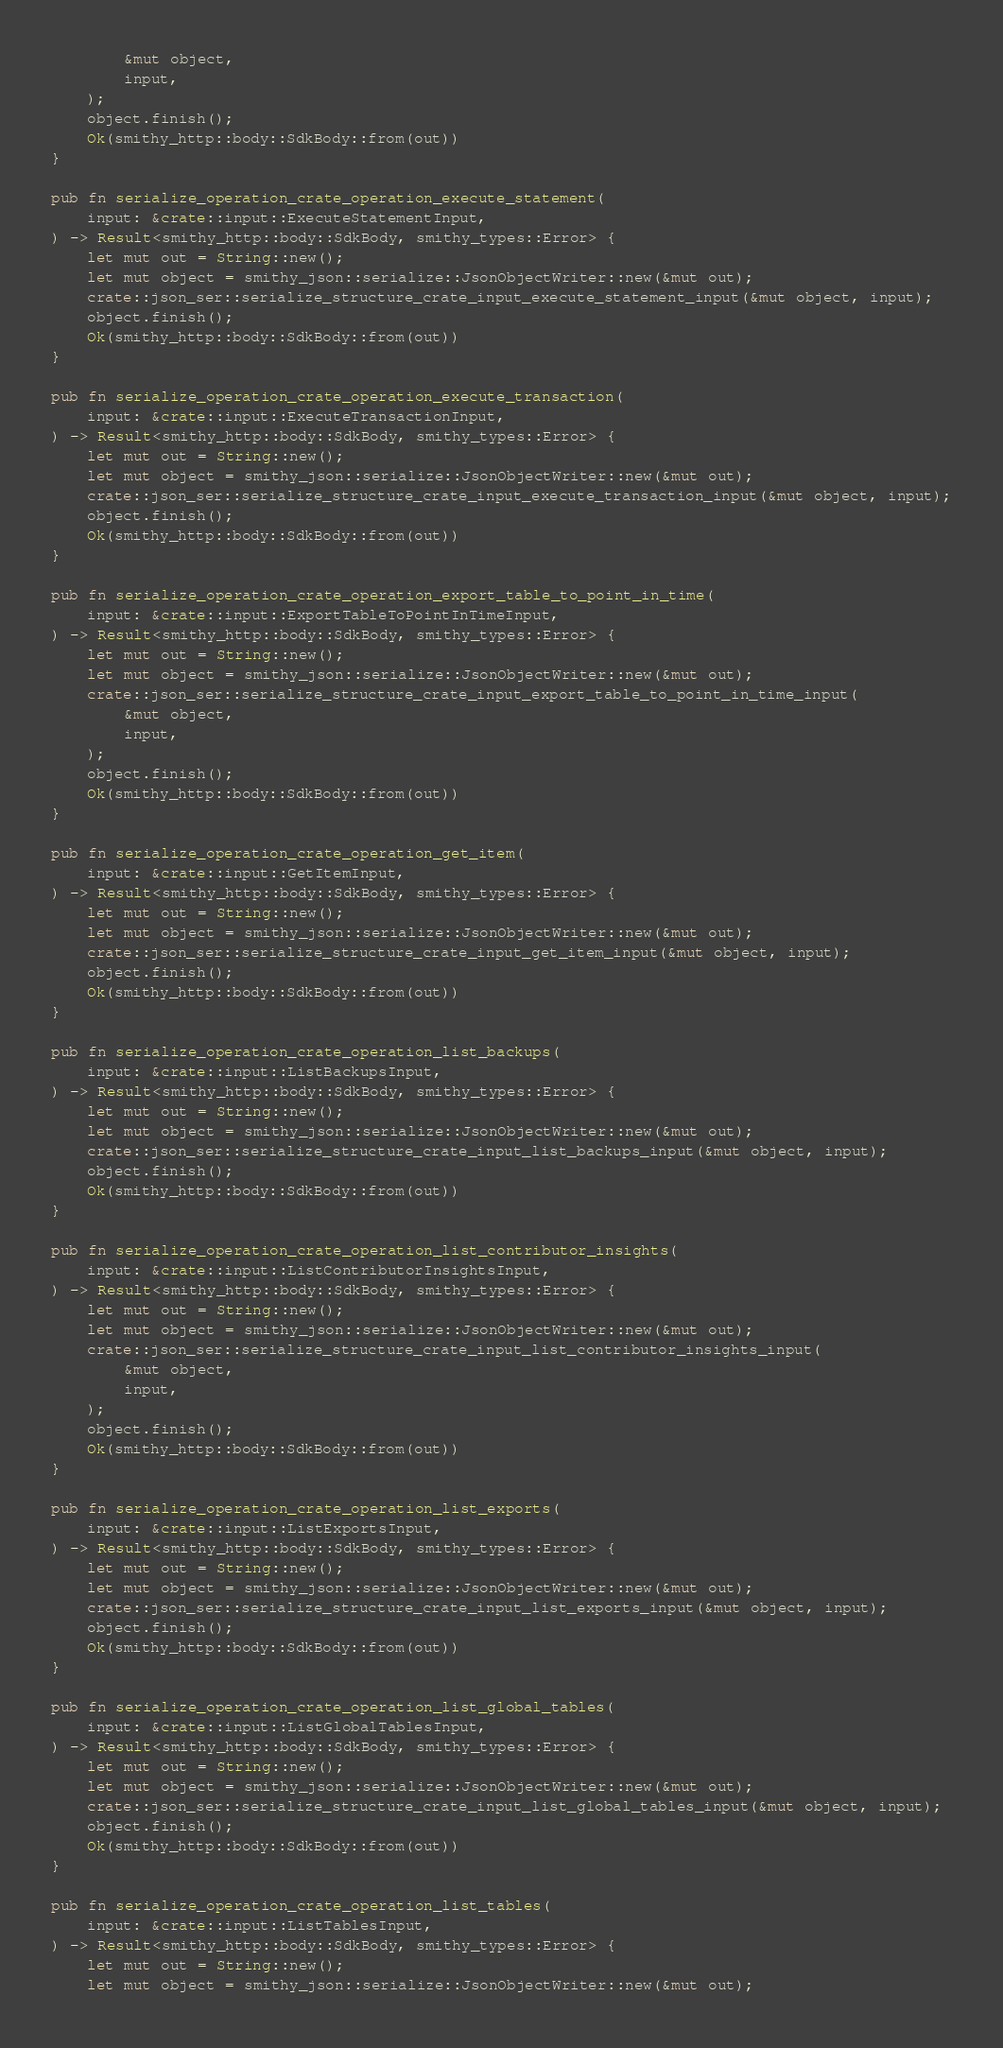<code> <loc_0><loc_0><loc_500><loc_500><_Rust_>        &mut object,
        input,
    );
    object.finish();
    Ok(smithy_http::body::SdkBody::from(out))
}

pub fn serialize_operation_crate_operation_execute_statement(
    input: &crate::input::ExecuteStatementInput,
) -> Result<smithy_http::body::SdkBody, smithy_types::Error> {
    let mut out = String::new();
    let mut object = smithy_json::serialize::JsonObjectWriter::new(&mut out);
    crate::json_ser::serialize_structure_crate_input_execute_statement_input(&mut object, input);
    object.finish();
    Ok(smithy_http::body::SdkBody::from(out))
}

pub fn serialize_operation_crate_operation_execute_transaction(
    input: &crate::input::ExecuteTransactionInput,
) -> Result<smithy_http::body::SdkBody, smithy_types::Error> {
    let mut out = String::new();
    let mut object = smithy_json::serialize::JsonObjectWriter::new(&mut out);
    crate::json_ser::serialize_structure_crate_input_execute_transaction_input(&mut object, input);
    object.finish();
    Ok(smithy_http::body::SdkBody::from(out))
}

pub fn serialize_operation_crate_operation_export_table_to_point_in_time(
    input: &crate::input::ExportTableToPointInTimeInput,
) -> Result<smithy_http::body::SdkBody, smithy_types::Error> {
    let mut out = String::new();
    let mut object = smithy_json::serialize::JsonObjectWriter::new(&mut out);
    crate::json_ser::serialize_structure_crate_input_export_table_to_point_in_time_input(
        &mut object,
        input,
    );
    object.finish();
    Ok(smithy_http::body::SdkBody::from(out))
}

pub fn serialize_operation_crate_operation_get_item(
    input: &crate::input::GetItemInput,
) -> Result<smithy_http::body::SdkBody, smithy_types::Error> {
    let mut out = String::new();
    let mut object = smithy_json::serialize::JsonObjectWriter::new(&mut out);
    crate::json_ser::serialize_structure_crate_input_get_item_input(&mut object, input);
    object.finish();
    Ok(smithy_http::body::SdkBody::from(out))
}

pub fn serialize_operation_crate_operation_list_backups(
    input: &crate::input::ListBackupsInput,
) -> Result<smithy_http::body::SdkBody, smithy_types::Error> {
    let mut out = String::new();
    let mut object = smithy_json::serialize::JsonObjectWriter::new(&mut out);
    crate::json_ser::serialize_structure_crate_input_list_backups_input(&mut object, input);
    object.finish();
    Ok(smithy_http::body::SdkBody::from(out))
}

pub fn serialize_operation_crate_operation_list_contributor_insights(
    input: &crate::input::ListContributorInsightsInput,
) -> Result<smithy_http::body::SdkBody, smithy_types::Error> {
    let mut out = String::new();
    let mut object = smithy_json::serialize::JsonObjectWriter::new(&mut out);
    crate::json_ser::serialize_structure_crate_input_list_contributor_insights_input(
        &mut object,
        input,
    );
    object.finish();
    Ok(smithy_http::body::SdkBody::from(out))
}

pub fn serialize_operation_crate_operation_list_exports(
    input: &crate::input::ListExportsInput,
) -> Result<smithy_http::body::SdkBody, smithy_types::Error> {
    let mut out = String::new();
    let mut object = smithy_json::serialize::JsonObjectWriter::new(&mut out);
    crate::json_ser::serialize_structure_crate_input_list_exports_input(&mut object, input);
    object.finish();
    Ok(smithy_http::body::SdkBody::from(out))
}

pub fn serialize_operation_crate_operation_list_global_tables(
    input: &crate::input::ListGlobalTablesInput,
) -> Result<smithy_http::body::SdkBody, smithy_types::Error> {
    let mut out = String::new();
    let mut object = smithy_json::serialize::JsonObjectWriter::new(&mut out);
    crate::json_ser::serialize_structure_crate_input_list_global_tables_input(&mut object, input);
    object.finish();
    Ok(smithy_http::body::SdkBody::from(out))
}

pub fn serialize_operation_crate_operation_list_tables(
    input: &crate::input::ListTablesInput,
) -> Result<smithy_http::body::SdkBody, smithy_types::Error> {
    let mut out = String::new();
    let mut object = smithy_json::serialize::JsonObjectWriter::new(&mut out);</code> 